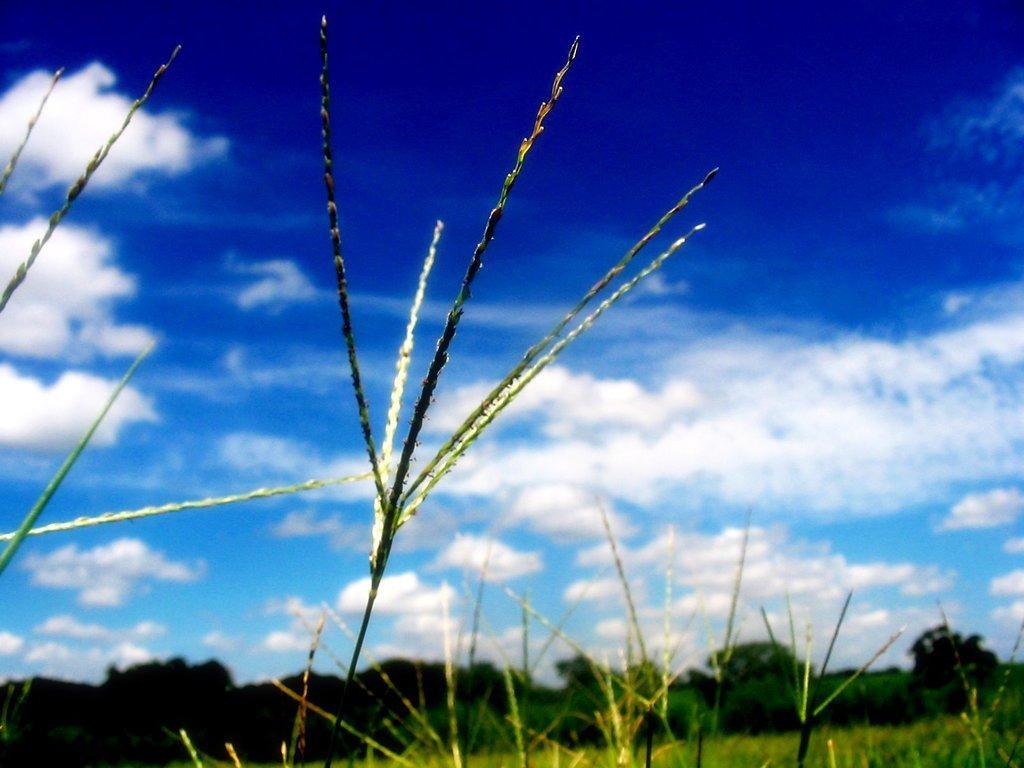Could you give a brief overview of what you see in this image? In this image we can see grass, trees and sky with clouds. 